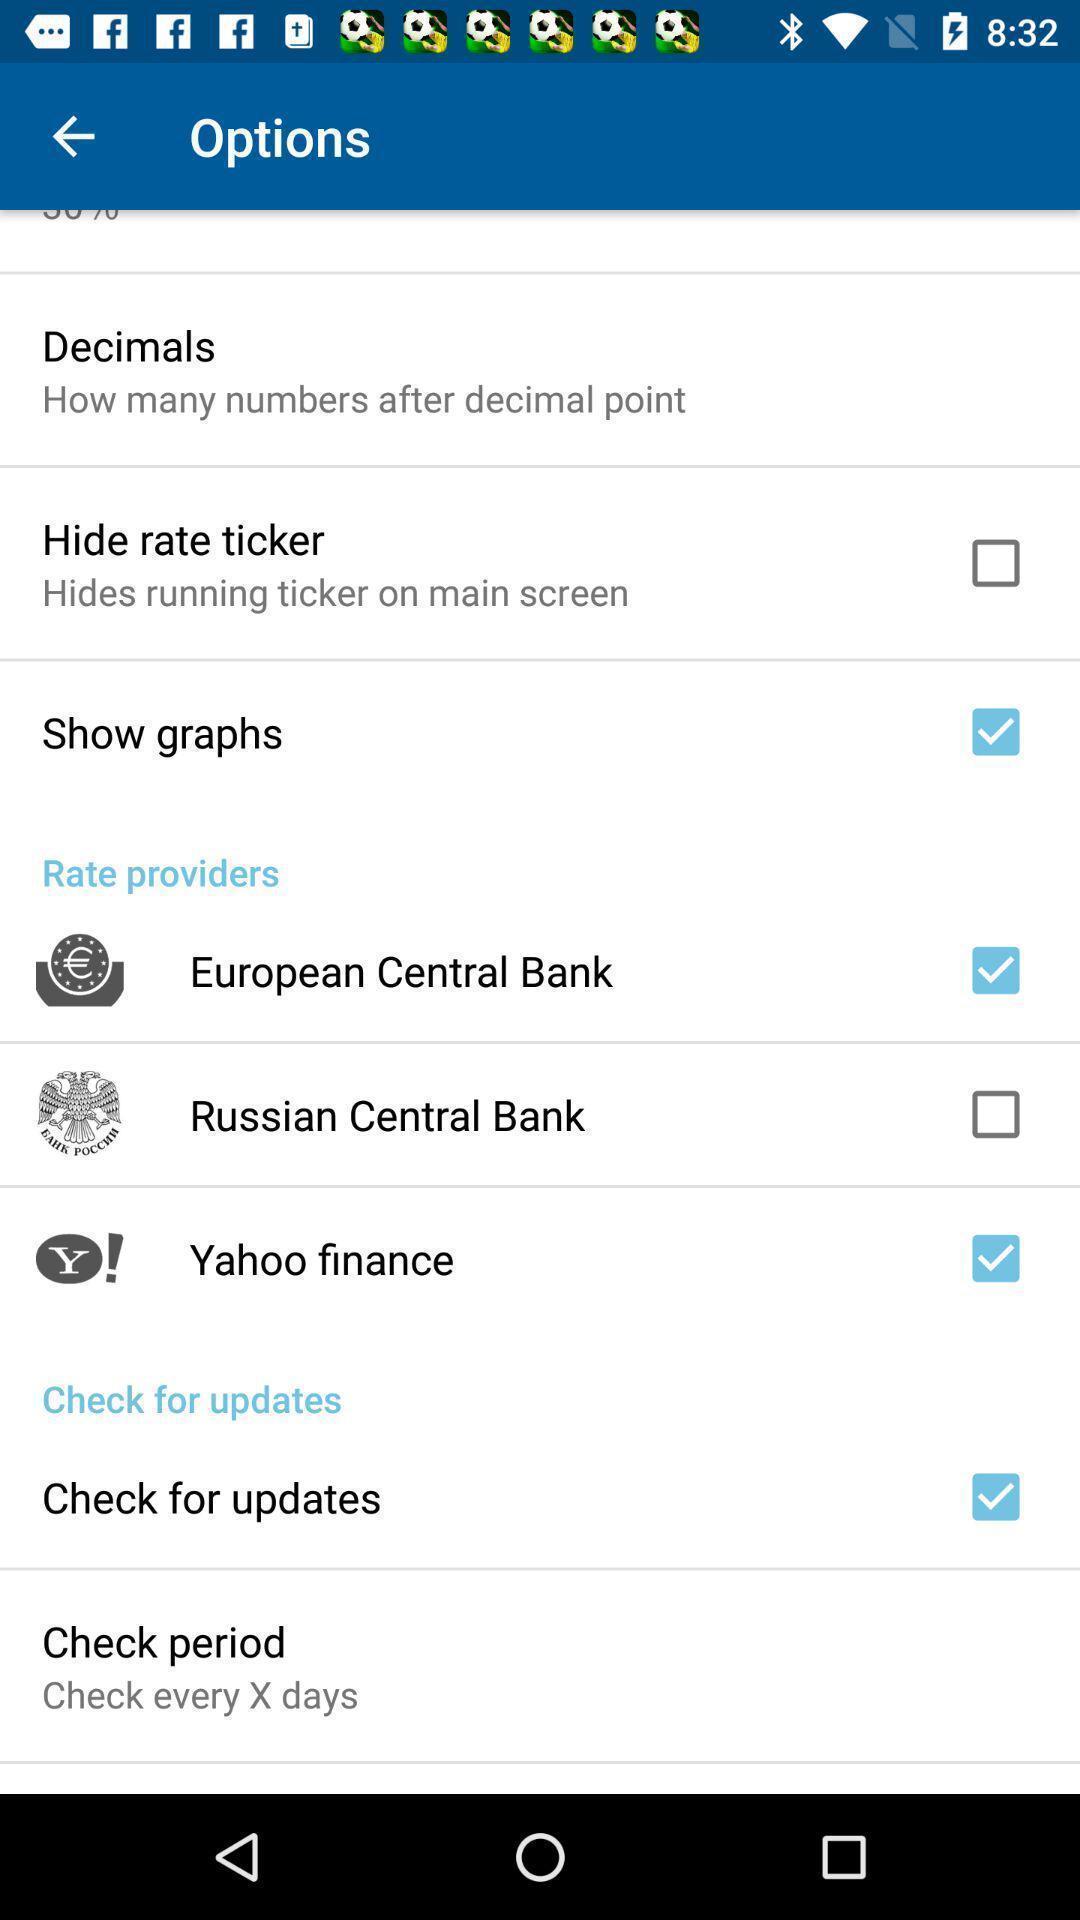Describe the visual elements of this screenshot. Screen shows different setting options. 